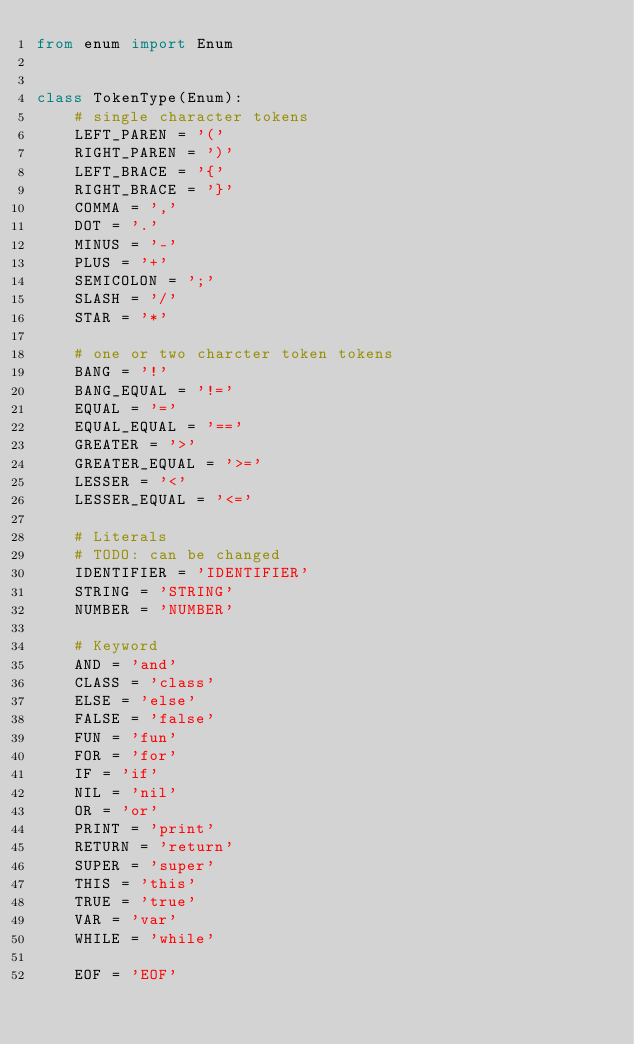Convert code to text. <code><loc_0><loc_0><loc_500><loc_500><_Python_>from enum import Enum


class TokenType(Enum):
    # single character tokens
    LEFT_PAREN = '('
    RIGHT_PAREN = ')'
    LEFT_BRACE = '{'
    RIGHT_BRACE = '}'
    COMMA = ','
    DOT = '.'
    MINUS = '-'
    PLUS = '+'
    SEMICOLON = ';'
    SLASH = '/'
    STAR = '*'

    # one or two charcter token tokens
    BANG = '!'
    BANG_EQUAL = '!='
    EQUAL = '='
    EQUAL_EQUAL = '=='
    GREATER = '>'
    GREATER_EQUAL = '>='
    LESSER = '<'
    LESSER_EQUAL = '<='

    # Literals
    # TODO: can be changed
    IDENTIFIER = 'IDENTIFIER'
    STRING = 'STRING'
    NUMBER = 'NUMBER'

    # Keyword
    AND = 'and'
    CLASS = 'class'
    ELSE = 'else'
    FALSE = 'false'
    FUN = 'fun'
    FOR = 'for'
    IF = 'if'
    NIL = 'nil'
    OR = 'or'
    PRINT = 'print'
    RETURN = 'return'
    SUPER = 'super'
    THIS = 'this'
    TRUE = 'true'
    VAR = 'var'
    WHILE = 'while'

    EOF = 'EOF'
</code> 